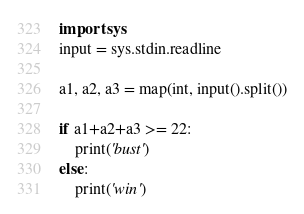Convert code to text. <code><loc_0><loc_0><loc_500><loc_500><_Python_>import sys
input = sys.stdin.readline

a1, a2, a3 = map(int, input().split())

if a1+a2+a3 >= 22:
    print('bust')
else:
    print('win')</code> 